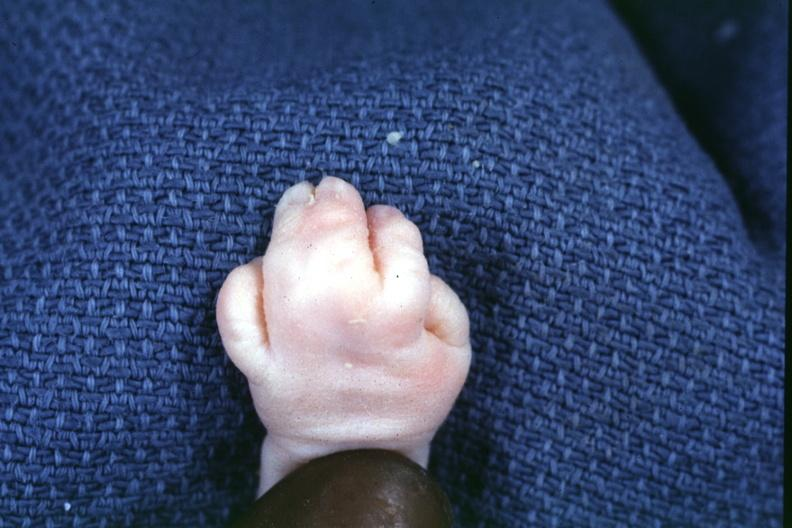s palmar crease normal present?
Answer the question using a single word or phrase. No 